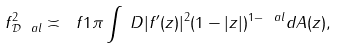Convert formula to latex. <formula><loc_0><loc_0><loc_500><loc_500>\| f \| ^ { 2 } _ { \mathcal { D } _ { \ } a l } \asymp \ f 1 \pi \int _ { \ } D | f ^ { \prime } ( z ) | ^ { 2 } ( 1 - | z | ) ^ { 1 - \ a l } d A ( z ) ,</formula> 